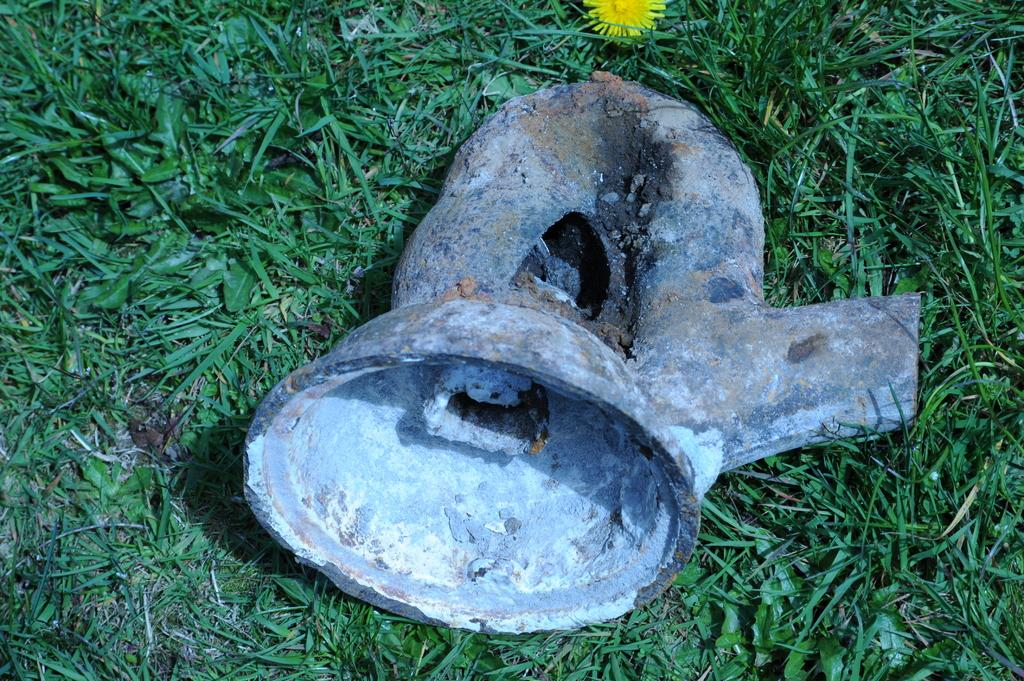What is the main subject in the image? There is an object in the image. What other element can be seen in the image? There is a flower in the image. Where are the object and the flower located? Both the object and the flower are on the grass. What level of difficulty is the flower running at in the image? There is no indication that the flower is running or has a level of difficulty in the image. 